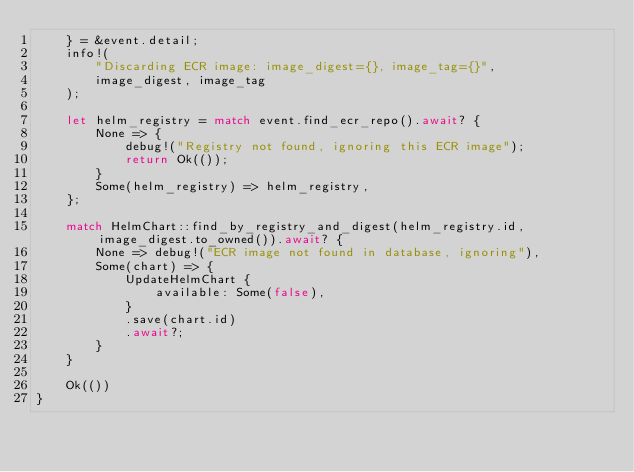Convert code to text. <code><loc_0><loc_0><loc_500><loc_500><_Rust_>    } = &event.detail;
    info!(
        "Discarding ECR image: image_digest={}, image_tag={}",
        image_digest, image_tag
    );

    let helm_registry = match event.find_ecr_repo().await? {
        None => {
            debug!("Registry not found, ignoring this ECR image");
            return Ok(());
        }
        Some(helm_registry) => helm_registry,
    };

    match HelmChart::find_by_registry_and_digest(helm_registry.id, image_digest.to_owned()).await? {
        None => debug!("ECR image not found in database, ignoring"),
        Some(chart) => {
            UpdateHelmChart {
                available: Some(false),
            }
            .save(chart.id)
            .await?;
        }
    }

    Ok(())
}
</code> 